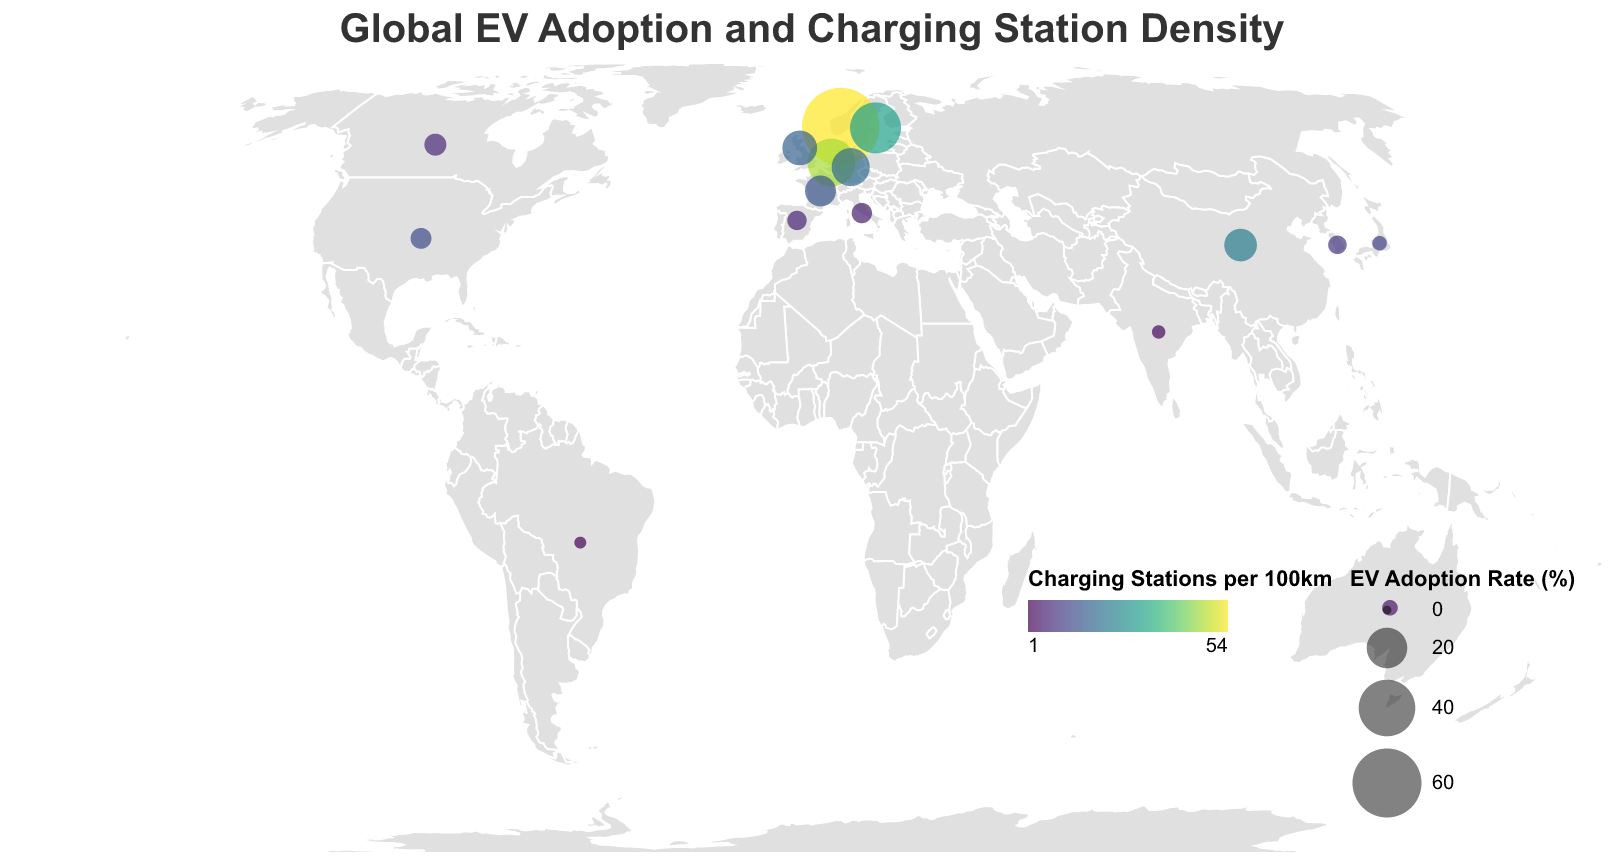What is the title of the figure? The title is always located at the top of the figure and describes the overall content. In this figure, the title is "Global EV Adoption and Charging Station Density".
Answer: Global EV Adoption and Charging Station Density Which country has the highest EV adoption rate? Look for the largest circle on the map as the size represents the EV adoption rate. Norway has the largest circle, indicating it has the highest EV adoption rate.
Answer: Norway Which country has the lowest number of charging stations per 100km? Identify the country with the palest color (representing fewer charging stations). Brazil has the lightest color, indicating it has the lowest number of charging stations per 100km.
Answer: Brazil What is the EV adoption rate of China? Hovering over China on the map will show a tooltip with detailed information including the EV adoption rate, which is 12.7%.
Answer: 12.7% Compare the EV adoption rates between Germany and the United Kingdom. Which is higher? Find the circles representing Germany and the United Kingdom and compare their sizes. Germany's circle is slightly larger, meaning it has a higher EV adoption rate.
Answer: Germany What is the average number of charging stations per 100km for Norway, Sweden, and the Netherlands? Add the number of charging stations for these countries (54 for Norway, 31 for Sweden, 47 for Netherlands), then divide by 3. Calculation: (54 + 31 + 47) / 3 = 132 / 3 = 44.
Answer: 44 How does the EV adoption rate in the United States compare to Japan? Locate the circles for the United States and Japan and compare their sizes. The United States has a larger circle, indicating a higher EV adoption rate.
Answer: United States Which country has more charging stations per 100km: France or Italy? Compare the color intensity of France and Italy. France (15 charging stations) has a more intense color than Italy (5 charging stations).
Answer: France What is the median EV adoption rate for the countries listed? List the EV adoption rates in ascending order and find the middle value. Ordered values: 0.8, 1.3, 1.7, 2.1, 3.4, 3.8, 4.3, 4.6, 5.2, 11.3, 12.7, 14.5, 17.6, 28.3, 32.2, 75.8. The median is the middle value (4.6).
Answer: 4.6 